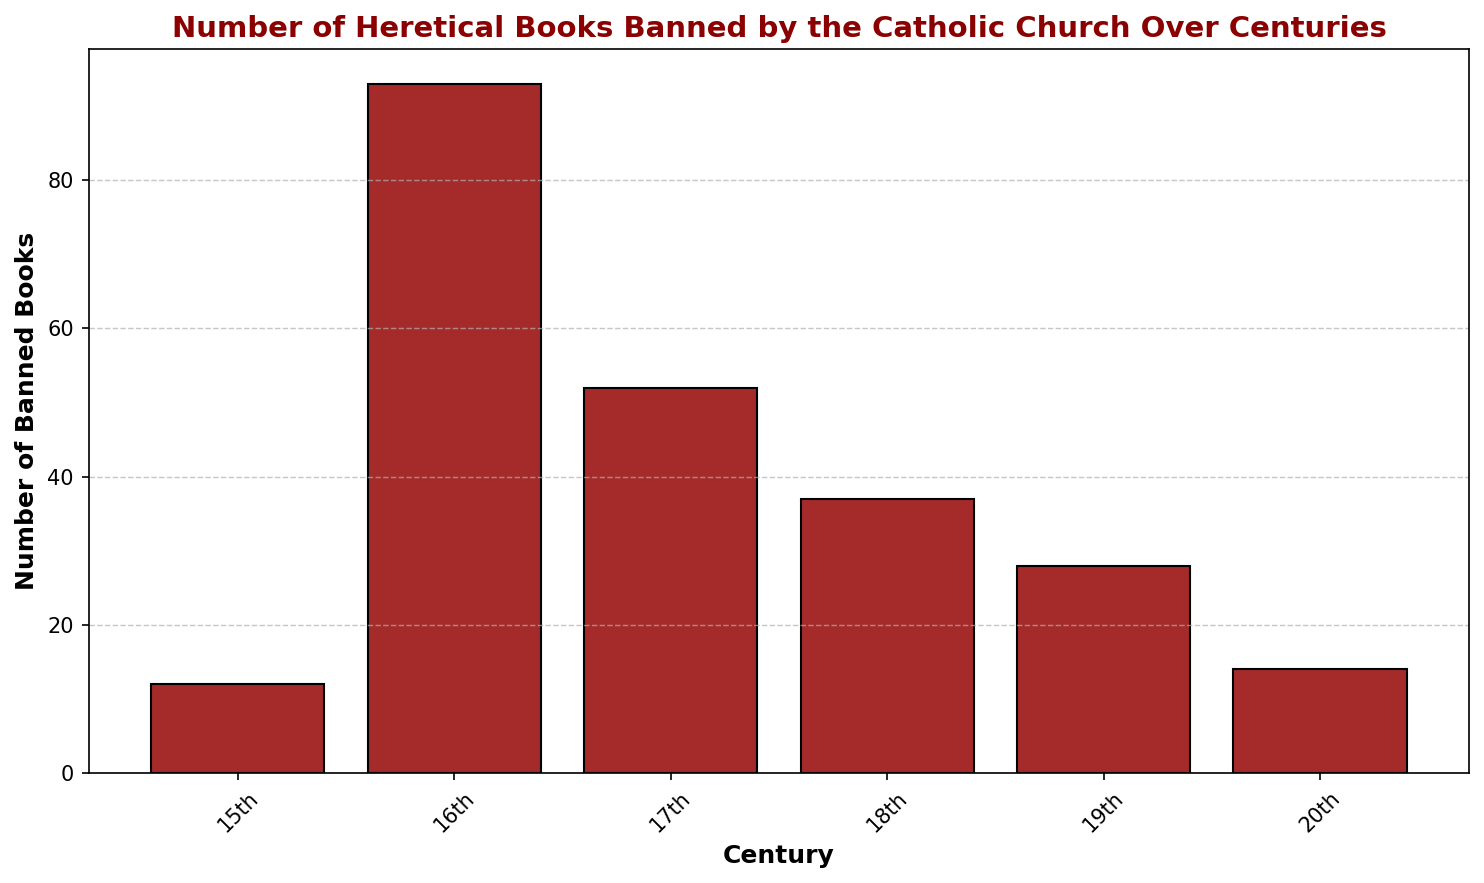How many heretical books were banned in total across all centuries shown? Sum the number of banned books from each century: 12 + 93 + 52 + 37 + 28 + 14 = 236
Answer: 236 In which century was the highest number of heretical books banned? Observe the bar heights for all centuries and note the tallest. The 16th century bar is the highest.
Answer: 16th century How many more heretical books were banned in the 16th century compared to the 20th century? Subtract the number of banned books in the 20th century from the 16th century: 93 - 14 = 79
Answer: 79 Which century had the least number of heretical books banned, and how many were they? Observe the bar heights and identify the shortest. The 15th century has the least number with 12 books.
Answer: 15th century, 12 What is the average number of heretical books banned per century? Calculate the total banned books and divide by the number of centuries: (12 + 93 + 52 + 37 + 28 + 14)/6 ≈ 39.33
Answer: Approximately 39.33 Which two consecutive centuries saw the biggest drop in the number of banned books, and what is the difference? Compare the decrease in numbers between each consecutive pair of centuries: Largest drop is between the 16th and 17th centuries (93 - 52 = 41)
Answer: 16th to 17th century, 41 What is the combined number of banned books for the 18th and 19th centuries? Sum the number of banned books: 37 + 28 = 65
Answer: 65 